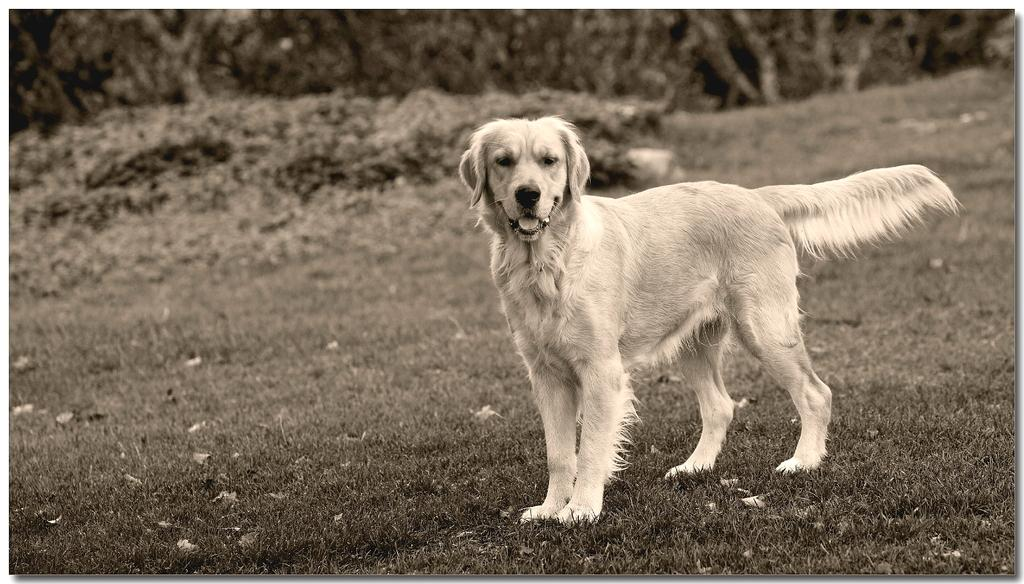What is the main subject in the front of the image? There is a dog in the front of the image. What can be seen in the background of the image? There are trees and plants in the background of the image. What is the condition of the ground in the image? Dry leaves are present on the ground. What type of book is the dog holding in the image? There is no book present in the image; the main subject is a dog. 